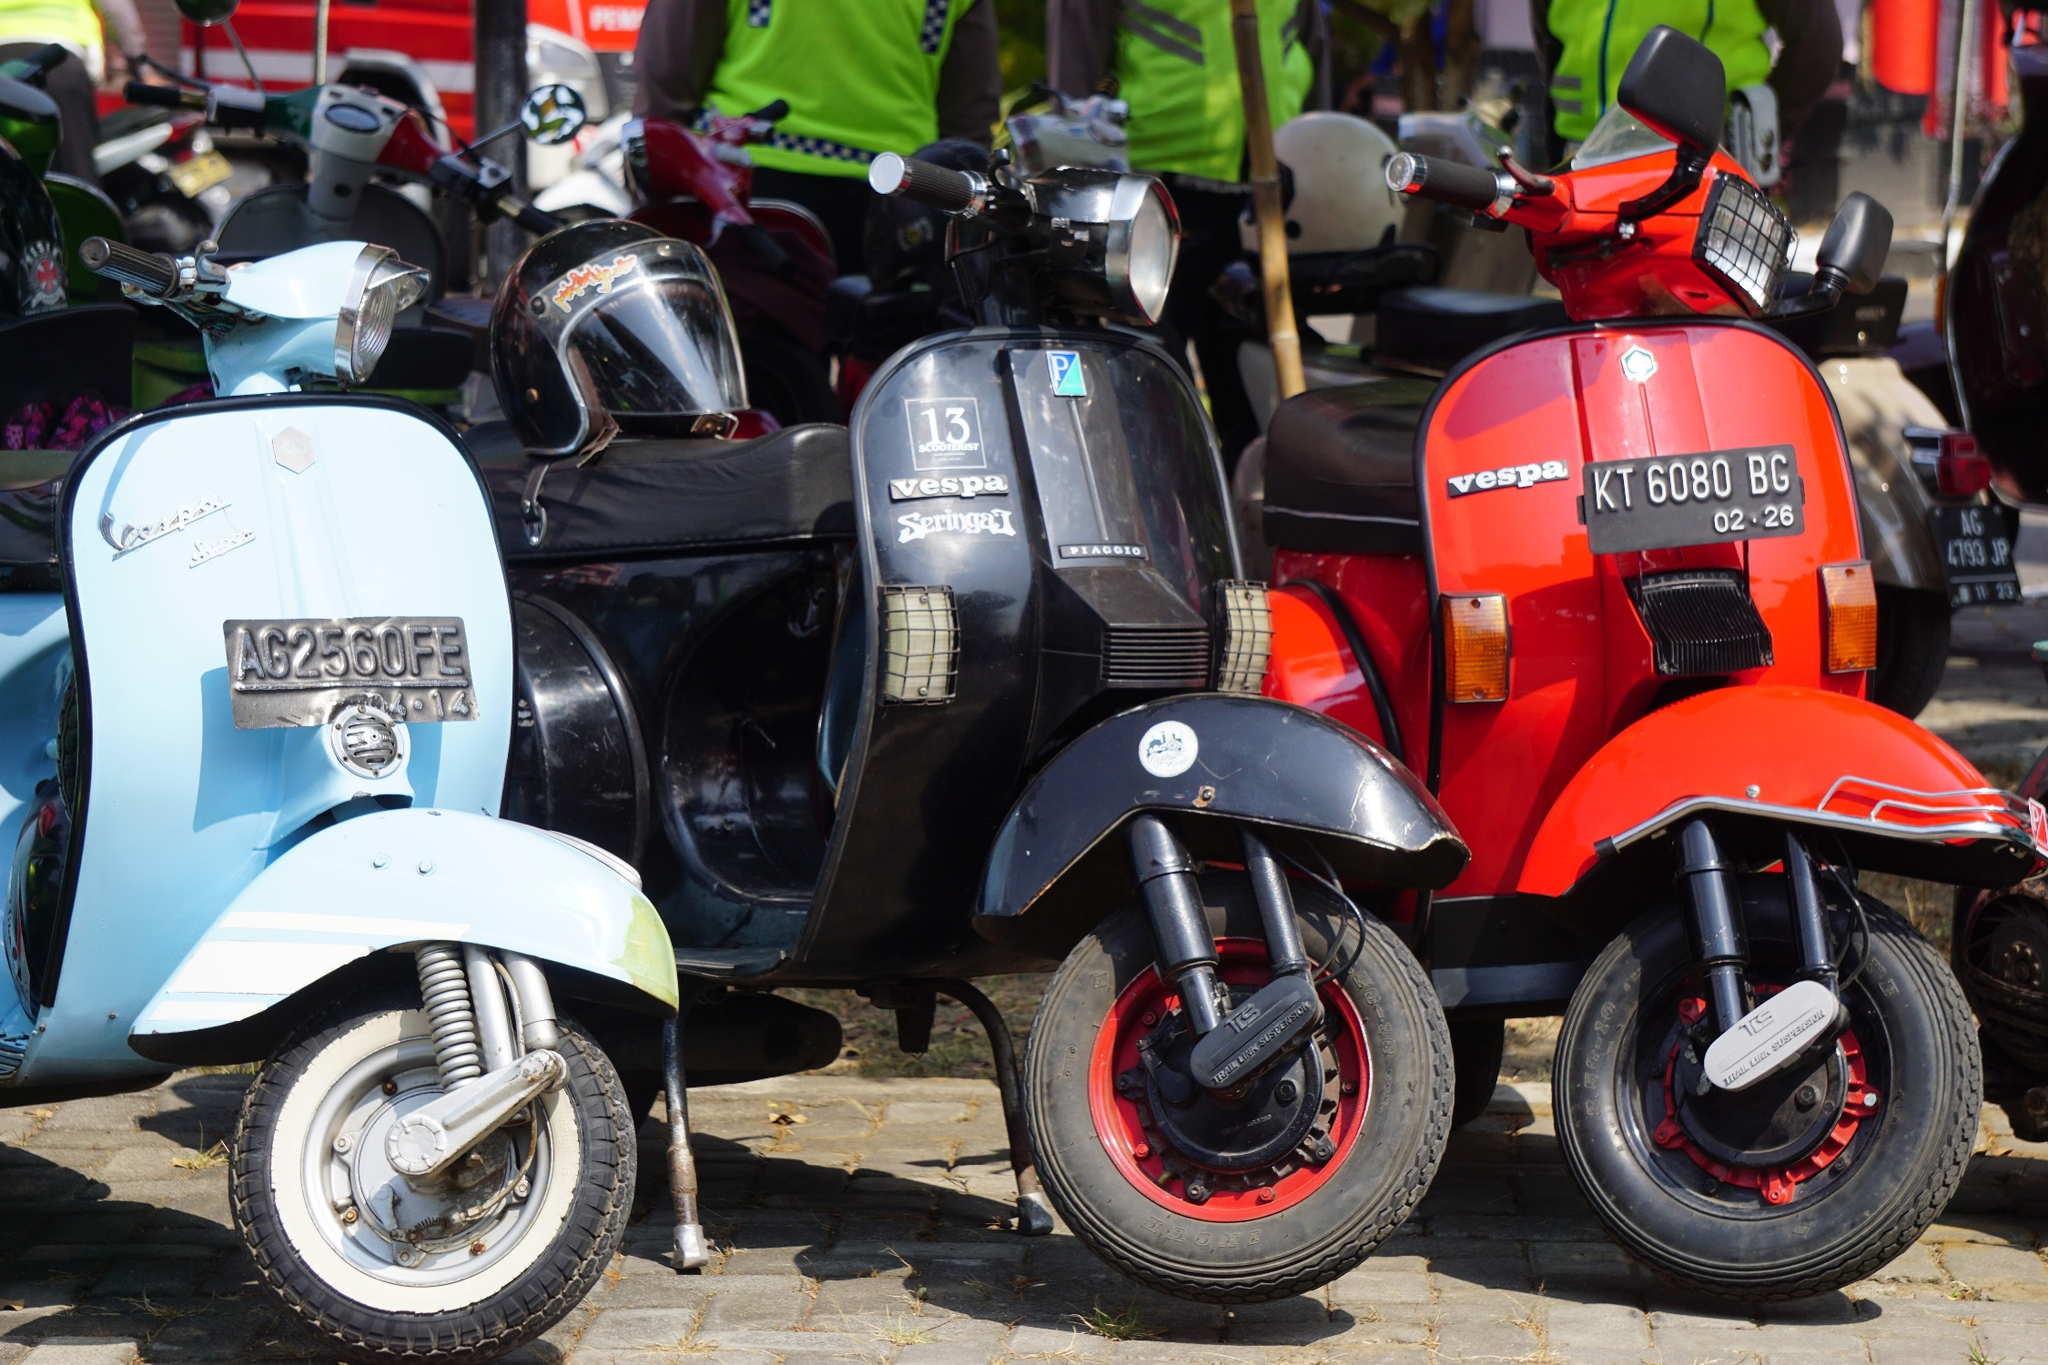Based on the image, envision a realistic scenario where we witness the daily routine of someone who rides one of these Vespas. Every morning, Marco, a resident of this enchanting town, hops on his vintage red Vespa for his daily commute. As the sun rises, he starts his journey from a cozy apartment adorned with ivy-clad walls. The Vespa glides smoothly over the cobblestone streets, past the local bakery where the aroma of freshly baked bread wafts through the air. Marco waves to the familiar faces he encounters daily – the elderly lady watering her plants, the butcher setting up his shop, and the school children waiting at the bus stop. His first stop is a quaint cafe where he picks up his usual – an espresso and a croissant. Then, it's off to the edge of town where he works as a manager in a family-owned vineyard. The Vespa’s agility allows him to navigate effortlessly through narrow lanes and winding roads. The ride gives him a few moments of tranquility, appreciating the charming landscape before the day's bustle begins.  What's a short, realistic daily scenario involving these Vespas? Every Sunday, Sofia rides her blue Vespa to the local market. The Vespa weaves through the narrow streets, making it easier for her to find parking. She visits various stalls, greeting the vendors she has known for years. After gathering fresh produce, she packs her bags into the Vespa's basket and rides back home, savoring the leisurely drive. 